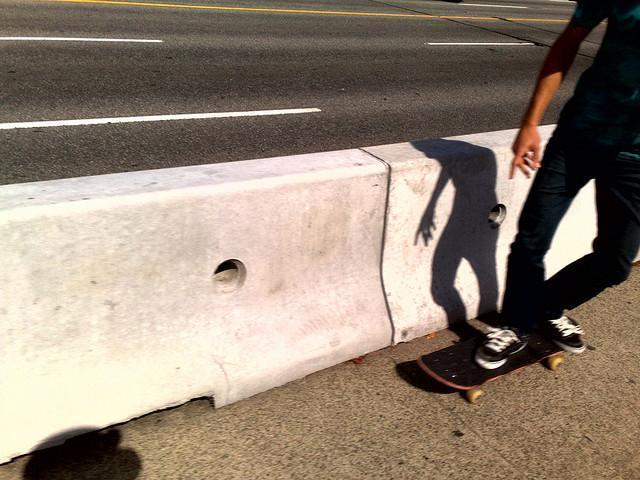How many motorcycles on the street?
Give a very brief answer. 0. 